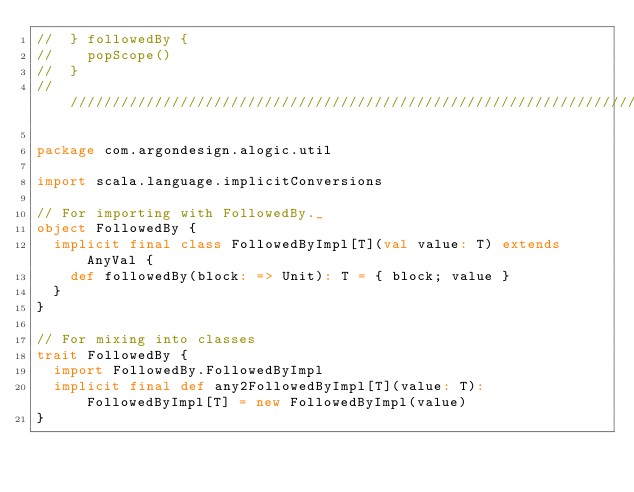Convert code to text. <code><loc_0><loc_0><loc_500><loc_500><_Scala_>//  } followedBy {
//    popScope()
//  }
////////////////////////////////////////////////////////////////////////////////

package com.argondesign.alogic.util

import scala.language.implicitConversions

// For importing with FollowedBy._
object FollowedBy {
  implicit final class FollowedByImpl[T](val value: T) extends AnyVal {
    def followedBy(block: => Unit): T = { block; value }
  }
}

// For mixing into classes
trait FollowedBy {
  import FollowedBy.FollowedByImpl
  implicit final def any2FollowedByImpl[T](value: T): FollowedByImpl[T] = new FollowedByImpl(value)
}
</code> 